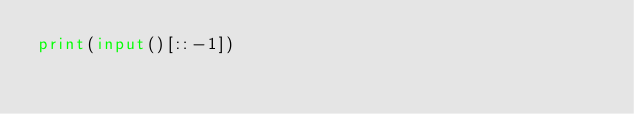<code> <loc_0><loc_0><loc_500><loc_500><_Python_>print(input()[::-1])</code> 